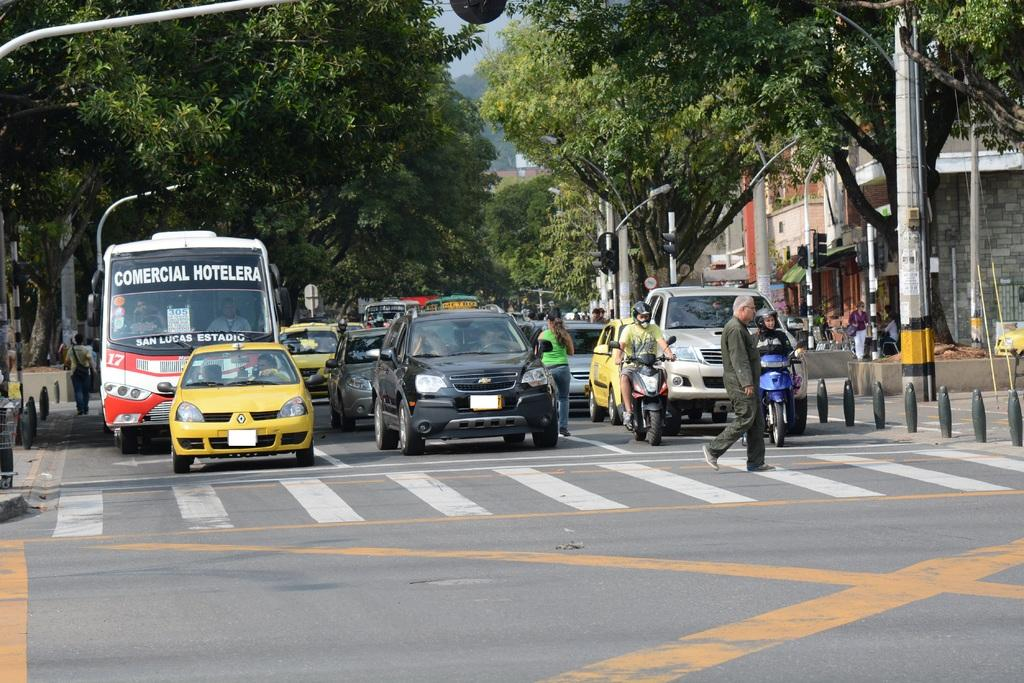What is happening on the road in the image? Vehicles and persons are on the road. What can be seen in the background of the image? There are signal light poles, buildings, and trees in the background. How are the two people positioned in the image? Two people are sitting on motorbikes. Can you see any snails crawling on the road in the image? No, there are no snails visible on the road in the image. Are there any cherries being dropped from the trees in the background? No, there are no cherries or trees dropping fruit in the image. 